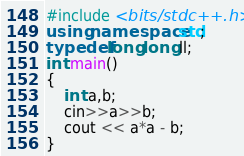<code> <loc_0><loc_0><loc_500><loc_500><_C++_>#include <bits/stdc++.h>
using namespace std;
typedef long long ll;
int main()
{
	int a,b;
	cin>>a>>b;
	cout << a*a - b;
}</code> 